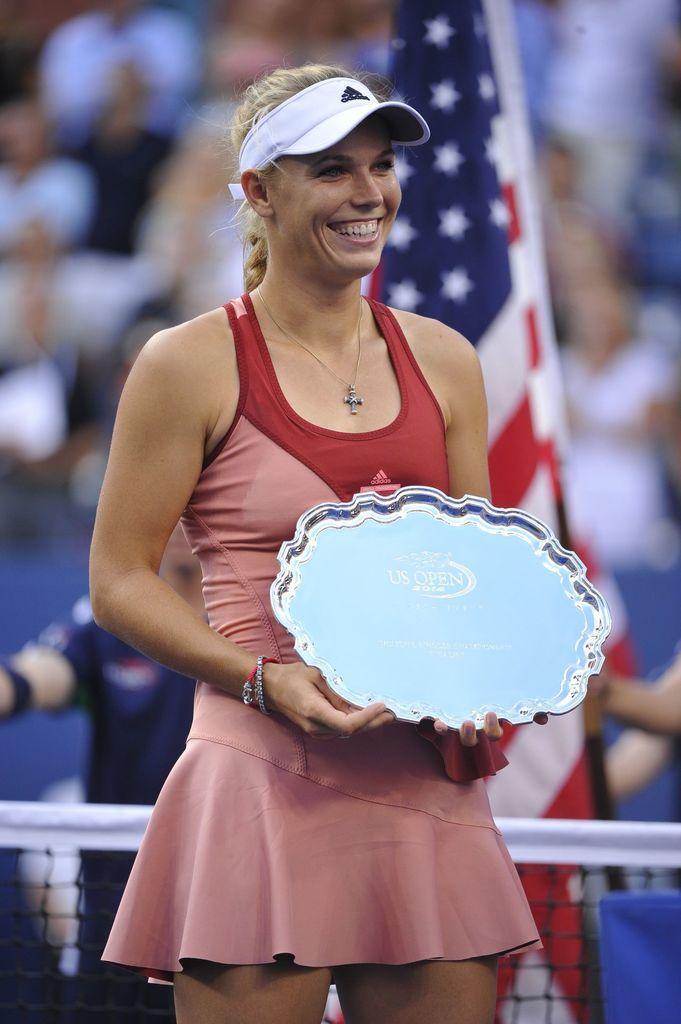In one or two sentences, can you explain what this image depicts? In this image we can see a lady wearing a cap is holding something in the hand. In the background there is flag. And also there are people. And there is a net. 